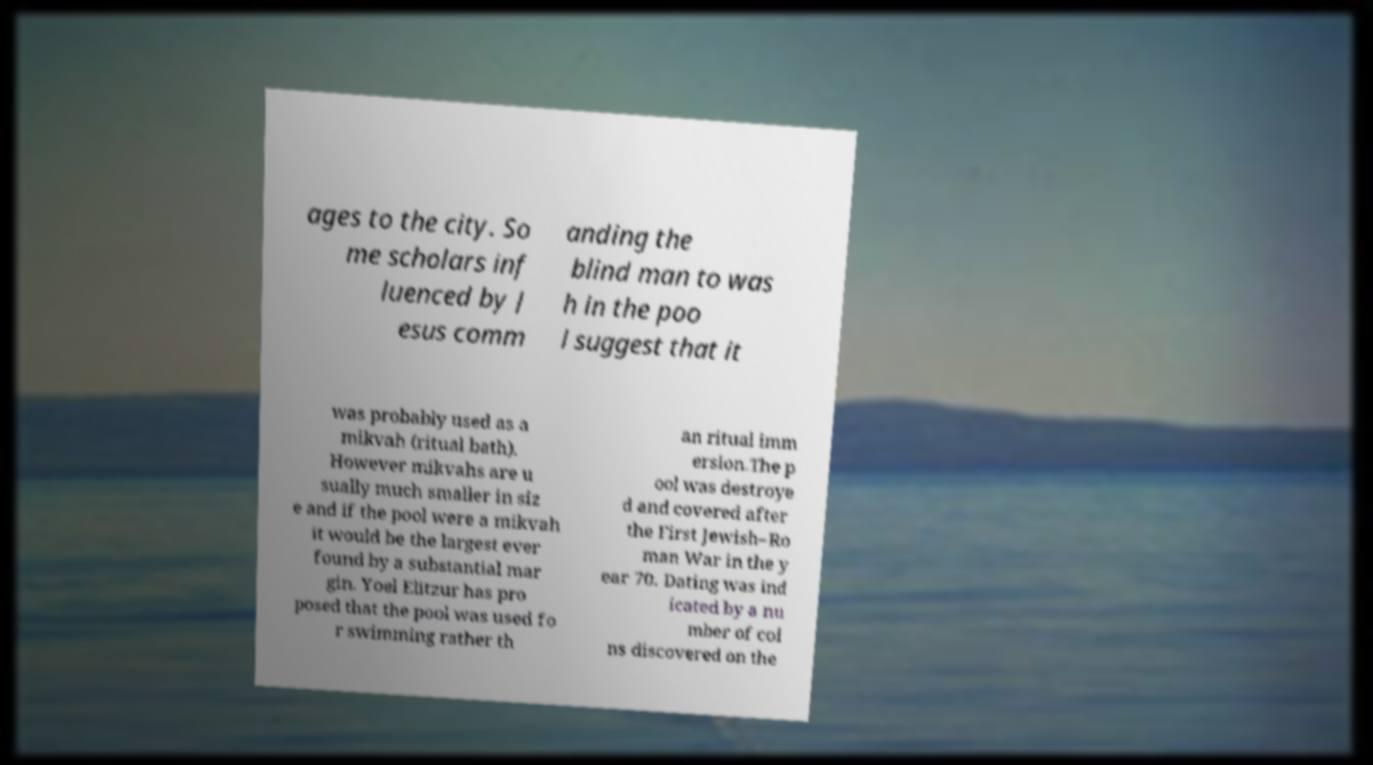Can you accurately transcribe the text from the provided image for me? ages to the city. So me scholars inf luenced by J esus comm anding the blind man to was h in the poo l suggest that it was probably used as a mikvah (ritual bath). However mikvahs are u sually much smaller in siz e and if the pool were a mikvah it would be the largest ever found by a substantial mar gin. Yoel Elitzur has pro posed that the pool was used fo r swimming rather th an ritual imm ersion.The p ool was destroye d and covered after the First Jewish–Ro man War in the y ear 70. Dating was ind icated by a nu mber of coi ns discovered on the 